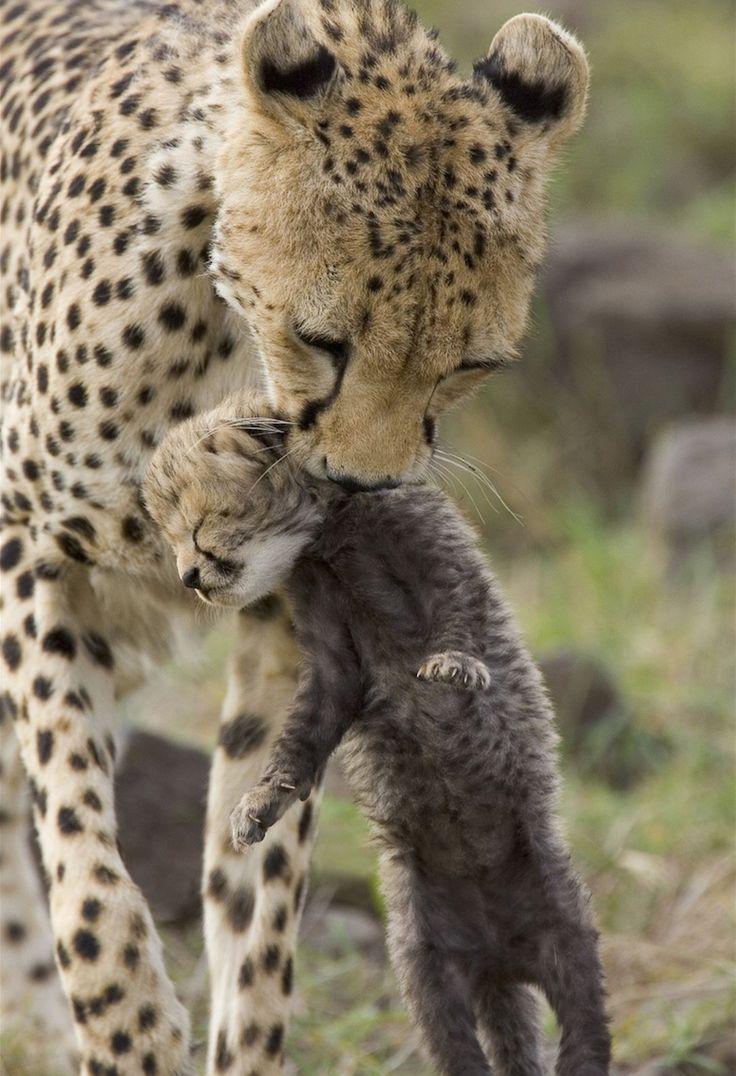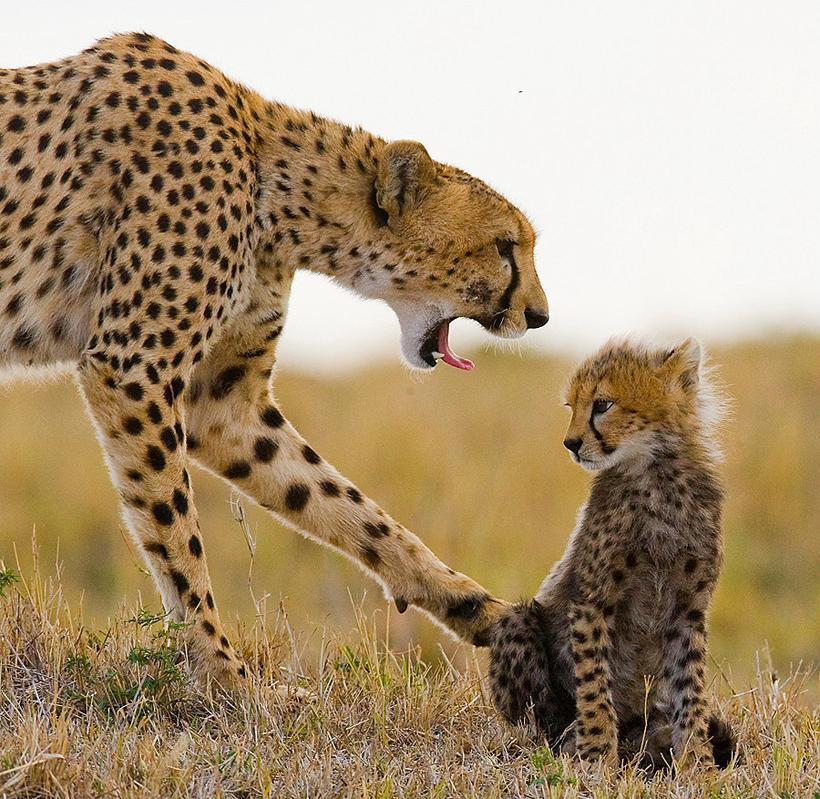The first image is the image on the left, the second image is the image on the right. Analyze the images presented: Is the assertion "A spotted adult wildcat is carrying a dangling kitten in its mouth in one image." valid? Answer yes or no. Yes. The first image is the image on the left, the second image is the image on the right. Assess this claim about the two images: "The left image contains two cheetahs.". Correct or not? Answer yes or no. Yes. 